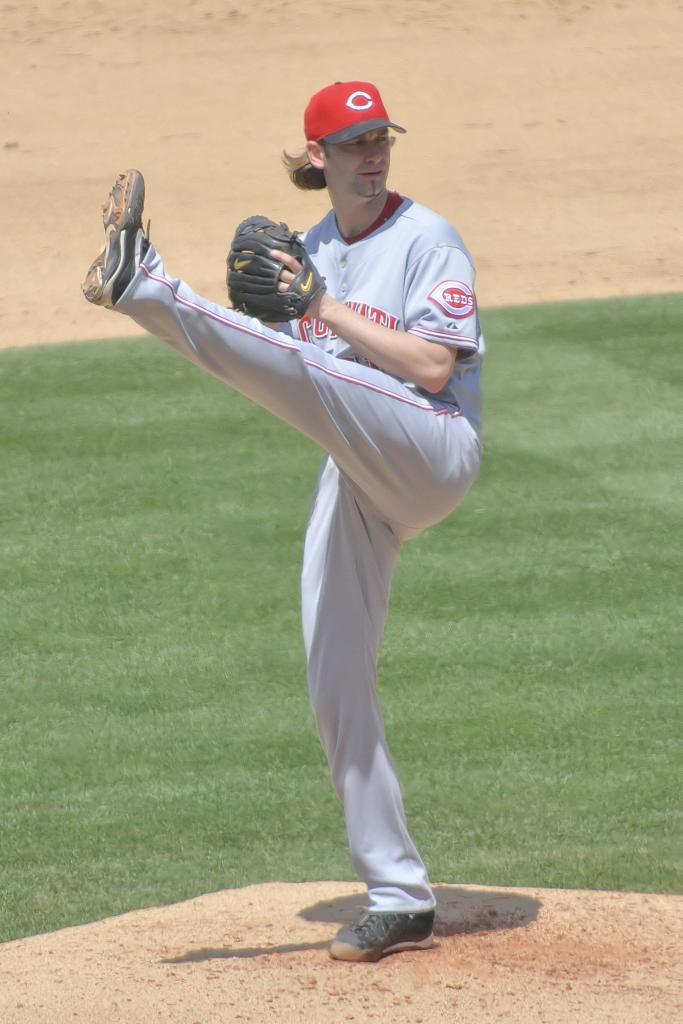In one or two sentences, can you explain what this image depicts? In the picture we can see a man in a sports wear standing on one leg and behind him we can see a part of the grass surface and behind it we can see a part of the muddy surface. 